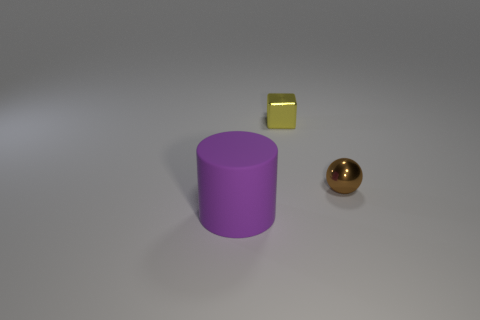Are there an equal number of large matte cylinders that are in front of the purple matte cylinder and blue matte balls?
Offer a very short reply. Yes. Is there anything else that is the same size as the purple matte cylinder?
Your answer should be very brief. No. There is a object that is the same size as the brown sphere; what is its shape?
Your answer should be very brief. Cube. Are there any spheres that are to the right of the small thing that is behind the small brown metallic thing in front of the tiny yellow shiny cube?
Provide a short and direct response. Yes. Is the number of tiny brown shiny spheres right of the small yellow object greater than the number of things that are right of the tiny brown sphere?
Ensure brevity in your answer.  Yes. What number of big objects are gray metal balls or brown spheres?
Give a very brief answer. 0. How many objects are both in front of the brown metal ball and to the right of the large cylinder?
Give a very brief answer. 0. The tiny thing that is made of the same material as the tiny brown ball is what shape?
Give a very brief answer. Cube. Does the yellow metallic cube have the same size as the rubber cylinder?
Provide a short and direct response. No. Do the tiny object to the right of the yellow object and the large purple cylinder have the same material?
Provide a succinct answer. No. 